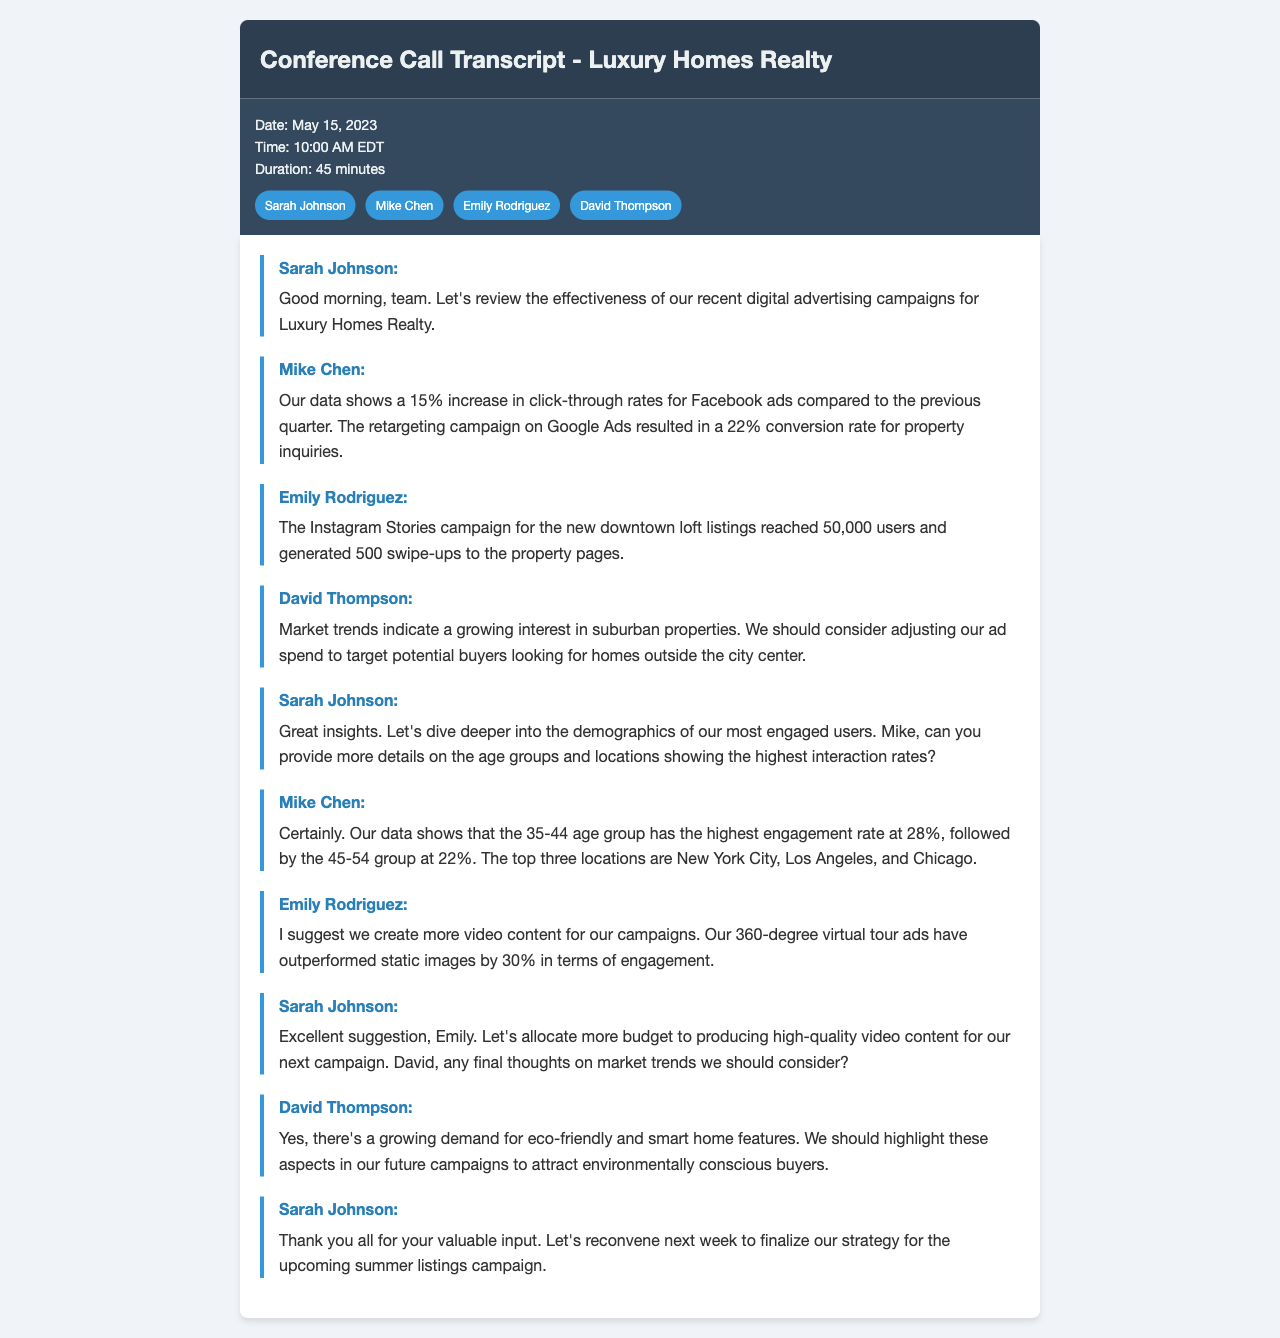What is the date of the conference call? The date is explicitly stated in the document under call details.
Answer: May 15, 2023 Who talked about the increase in click-through rates for Facebook ads? The speaker identifies themselves while discussing specific campaign performance metrics.
Answer: Mike Chen What is the conversion rate for the retargeting campaign on Google Ads? The document provides clear numerical data regarding the effectiveness of the campaign.
Answer: 22% Which age group has the highest engagement rate? The information is gathered from Mike Chen's analysis of demographic data related to user engagement.
Answer: 35-44 What type of content does Emily Rodriguez suggest creating more of? The suggestion is noted during the discussion of content engagement performance.
Answer: Video content What are the top three cities mentioned for user engagement? The document lists the top locations from the demographic data presented in the meeting.
Answer: New York City, Los Angeles, Chicago What aspect of home features does David Thompson highlight for future campaigns? The focus on specific home features emerges during discussions on market trends.
Answer: Eco-friendly and smart home features What is the duration of the conference call? The duration is listed in the call details section of the transcript.
Answer: 45 minutes 